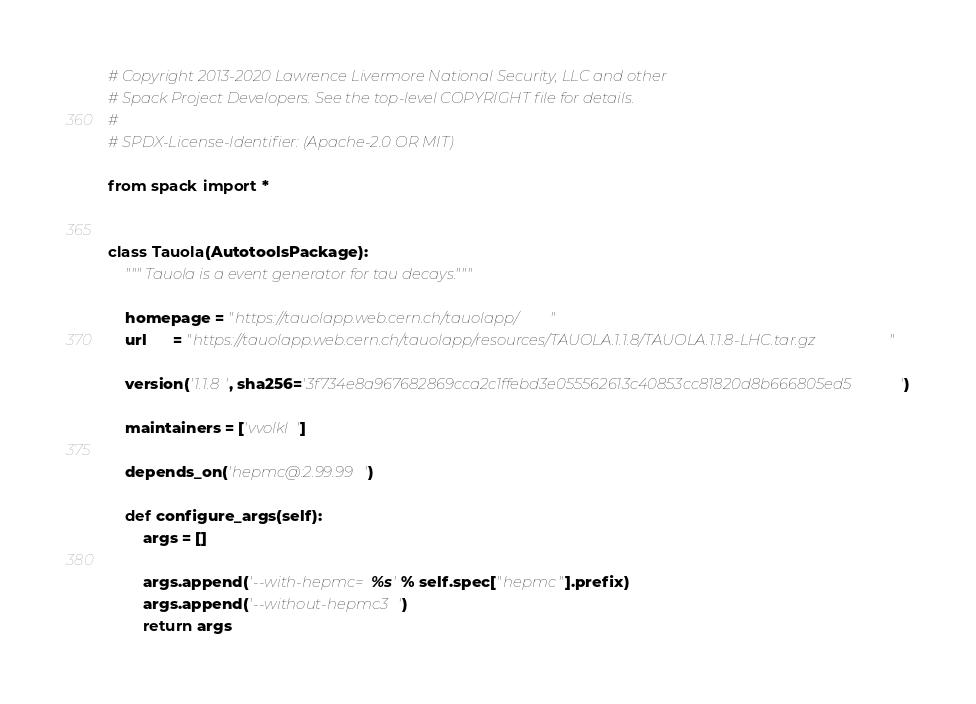<code> <loc_0><loc_0><loc_500><loc_500><_Python_># Copyright 2013-2020 Lawrence Livermore National Security, LLC and other
# Spack Project Developers. See the top-level COPYRIGHT file for details.
#
# SPDX-License-Identifier: (Apache-2.0 OR MIT)

from spack import *


class Tauola(AutotoolsPackage):
    """ Tauola is a event generator for tau decays."""

    homepage = "https://tauolapp.web.cern.ch/tauolapp/"
    url      = "https://tauolapp.web.cern.ch/tauolapp/resources/TAUOLA.1.1.8/TAUOLA.1.1.8-LHC.tar.gz"

    version('1.1.8', sha256='3f734e8a967682869cca2c1ffebd3e055562613c40853cc81820d8b666805ed5')

    maintainers = ['vvolkl']

    depends_on('hepmc@:2.99.99')

    def configure_args(self):
        args = []

        args.append('--with-hepmc=%s' % self.spec["hepmc"].prefix)
        args.append('--without-hepmc3')
        return args
</code> 